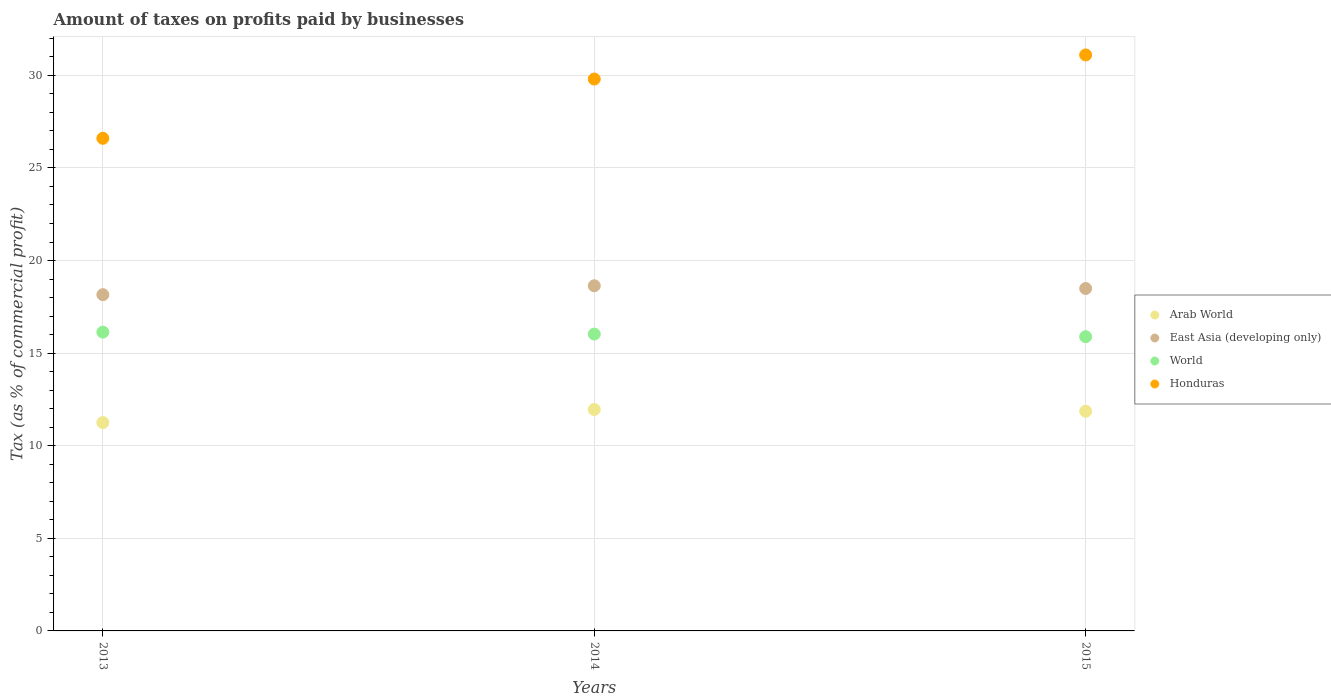What is the percentage of taxes paid by businesses in Honduras in 2013?
Offer a terse response. 26.6. Across all years, what is the maximum percentage of taxes paid by businesses in World?
Your answer should be compact. 16.13. Across all years, what is the minimum percentage of taxes paid by businesses in Arab World?
Your answer should be very brief. 11.25. In which year was the percentage of taxes paid by businesses in East Asia (developing only) maximum?
Your answer should be compact. 2014. What is the total percentage of taxes paid by businesses in East Asia (developing only) in the graph?
Ensure brevity in your answer.  55.28. What is the difference between the percentage of taxes paid by businesses in East Asia (developing only) in 2014 and that in 2015?
Provide a short and direct response. 0.15. What is the difference between the percentage of taxes paid by businesses in Arab World in 2015 and the percentage of taxes paid by businesses in East Asia (developing only) in 2013?
Keep it short and to the point. -6.29. What is the average percentage of taxes paid by businesses in Arab World per year?
Ensure brevity in your answer.  11.69. In the year 2015, what is the difference between the percentage of taxes paid by businesses in East Asia (developing only) and percentage of taxes paid by businesses in World?
Give a very brief answer. 2.6. In how many years, is the percentage of taxes paid by businesses in World greater than 23 %?
Offer a very short reply. 0. What is the ratio of the percentage of taxes paid by businesses in Arab World in 2013 to that in 2014?
Ensure brevity in your answer.  0.94. Is the difference between the percentage of taxes paid by businesses in East Asia (developing only) in 2013 and 2014 greater than the difference between the percentage of taxes paid by businesses in World in 2013 and 2014?
Offer a very short reply. No. What is the difference between the highest and the second highest percentage of taxes paid by businesses in World?
Offer a terse response. 0.11. What is the difference between the highest and the lowest percentage of taxes paid by businesses in World?
Keep it short and to the point. 0.25. Is it the case that in every year, the sum of the percentage of taxes paid by businesses in East Asia (developing only) and percentage of taxes paid by businesses in Honduras  is greater than the sum of percentage of taxes paid by businesses in World and percentage of taxes paid by businesses in Arab World?
Ensure brevity in your answer.  Yes. Is it the case that in every year, the sum of the percentage of taxes paid by businesses in Arab World and percentage of taxes paid by businesses in Honduras  is greater than the percentage of taxes paid by businesses in World?
Your answer should be very brief. Yes. Is the percentage of taxes paid by businesses in Arab World strictly greater than the percentage of taxes paid by businesses in Honduras over the years?
Offer a terse response. No. Is the percentage of taxes paid by businesses in Arab World strictly less than the percentage of taxes paid by businesses in World over the years?
Offer a very short reply. Yes. How many dotlines are there?
Offer a very short reply. 4. How many years are there in the graph?
Make the answer very short. 3. Are the values on the major ticks of Y-axis written in scientific E-notation?
Ensure brevity in your answer.  No. Does the graph contain any zero values?
Offer a very short reply. No. Does the graph contain grids?
Offer a very short reply. Yes. Where does the legend appear in the graph?
Your answer should be very brief. Center right. How many legend labels are there?
Your response must be concise. 4. What is the title of the graph?
Give a very brief answer. Amount of taxes on profits paid by businesses. What is the label or title of the X-axis?
Keep it short and to the point. Years. What is the label or title of the Y-axis?
Provide a succinct answer. Tax (as % of commercial profit). What is the Tax (as % of commercial profit) of Arab World in 2013?
Your response must be concise. 11.25. What is the Tax (as % of commercial profit) in East Asia (developing only) in 2013?
Provide a short and direct response. 18.16. What is the Tax (as % of commercial profit) of World in 2013?
Make the answer very short. 16.13. What is the Tax (as % of commercial profit) in Honduras in 2013?
Offer a very short reply. 26.6. What is the Tax (as % of commercial profit) of Arab World in 2014?
Offer a terse response. 11.96. What is the Tax (as % of commercial profit) of East Asia (developing only) in 2014?
Keep it short and to the point. 18.64. What is the Tax (as % of commercial profit) of World in 2014?
Make the answer very short. 16.03. What is the Tax (as % of commercial profit) of Honduras in 2014?
Offer a very short reply. 29.8. What is the Tax (as % of commercial profit) in Arab World in 2015?
Your answer should be very brief. 11.86. What is the Tax (as % of commercial profit) of East Asia (developing only) in 2015?
Provide a short and direct response. 18.49. What is the Tax (as % of commercial profit) of World in 2015?
Offer a terse response. 15.89. What is the Tax (as % of commercial profit) of Honduras in 2015?
Provide a short and direct response. 31.1. Across all years, what is the maximum Tax (as % of commercial profit) in Arab World?
Ensure brevity in your answer.  11.96. Across all years, what is the maximum Tax (as % of commercial profit) in East Asia (developing only)?
Offer a very short reply. 18.64. Across all years, what is the maximum Tax (as % of commercial profit) in World?
Provide a succinct answer. 16.13. Across all years, what is the maximum Tax (as % of commercial profit) in Honduras?
Offer a terse response. 31.1. Across all years, what is the minimum Tax (as % of commercial profit) of Arab World?
Your answer should be compact. 11.25. Across all years, what is the minimum Tax (as % of commercial profit) of East Asia (developing only)?
Your answer should be very brief. 18.16. Across all years, what is the minimum Tax (as % of commercial profit) in World?
Offer a terse response. 15.89. Across all years, what is the minimum Tax (as % of commercial profit) in Honduras?
Offer a terse response. 26.6. What is the total Tax (as % of commercial profit) in Arab World in the graph?
Give a very brief answer. 35.07. What is the total Tax (as % of commercial profit) in East Asia (developing only) in the graph?
Offer a terse response. 55.28. What is the total Tax (as % of commercial profit) in World in the graph?
Make the answer very short. 48.05. What is the total Tax (as % of commercial profit) in Honduras in the graph?
Provide a succinct answer. 87.5. What is the difference between the Tax (as % of commercial profit) in Arab World in 2013 and that in 2014?
Your answer should be compact. -0.71. What is the difference between the Tax (as % of commercial profit) of East Asia (developing only) in 2013 and that in 2014?
Ensure brevity in your answer.  -0.48. What is the difference between the Tax (as % of commercial profit) in World in 2013 and that in 2014?
Keep it short and to the point. 0.11. What is the difference between the Tax (as % of commercial profit) in Arab World in 2013 and that in 2015?
Provide a succinct answer. -0.61. What is the difference between the Tax (as % of commercial profit) in East Asia (developing only) in 2013 and that in 2015?
Your answer should be compact. -0.33. What is the difference between the Tax (as % of commercial profit) in World in 2013 and that in 2015?
Provide a succinct answer. 0.25. What is the difference between the Tax (as % of commercial profit) of Arab World in 2014 and that in 2015?
Your answer should be compact. 0.1. What is the difference between the Tax (as % of commercial profit) of East Asia (developing only) in 2014 and that in 2015?
Provide a succinct answer. 0.15. What is the difference between the Tax (as % of commercial profit) of World in 2014 and that in 2015?
Ensure brevity in your answer.  0.14. What is the difference between the Tax (as % of commercial profit) of Honduras in 2014 and that in 2015?
Make the answer very short. -1.3. What is the difference between the Tax (as % of commercial profit) in Arab World in 2013 and the Tax (as % of commercial profit) in East Asia (developing only) in 2014?
Your answer should be very brief. -7.39. What is the difference between the Tax (as % of commercial profit) of Arab World in 2013 and the Tax (as % of commercial profit) of World in 2014?
Provide a succinct answer. -4.78. What is the difference between the Tax (as % of commercial profit) in Arab World in 2013 and the Tax (as % of commercial profit) in Honduras in 2014?
Offer a terse response. -18.55. What is the difference between the Tax (as % of commercial profit) in East Asia (developing only) in 2013 and the Tax (as % of commercial profit) in World in 2014?
Ensure brevity in your answer.  2.13. What is the difference between the Tax (as % of commercial profit) in East Asia (developing only) in 2013 and the Tax (as % of commercial profit) in Honduras in 2014?
Give a very brief answer. -11.64. What is the difference between the Tax (as % of commercial profit) of World in 2013 and the Tax (as % of commercial profit) of Honduras in 2014?
Your answer should be very brief. -13.67. What is the difference between the Tax (as % of commercial profit) of Arab World in 2013 and the Tax (as % of commercial profit) of East Asia (developing only) in 2015?
Your response must be concise. -7.24. What is the difference between the Tax (as % of commercial profit) of Arab World in 2013 and the Tax (as % of commercial profit) of World in 2015?
Keep it short and to the point. -4.64. What is the difference between the Tax (as % of commercial profit) in Arab World in 2013 and the Tax (as % of commercial profit) in Honduras in 2015?
Your answer should be very brief. -19.85. What is the difference between the Tax (as % of commercial profit) of East Asia (developing only) in 2013 and the Tax (as % of commercial profit) of World in 2015?
Give a very brief answer. 2.27. What is the difference between the Tax (as % of commercial profit) of East Asia (developing only) in 2013 and the Tax (as % of commercial profit) of Honduras in 2015?
Provide a succinct answer. -12.94. What is the difference between the Tax (as % of commercial profit) of World in 2013 and the Tax (as % of commercial profit) of Honduras in 2015?
Provide a short and direct response. -14.97. What is the difference between the Tax (as % of commercial profit) in Arab World in 2014 and the Tax (as % of commercial profit) in East Asia (developing only) in 2015?
Give a very brief answer. -6.53. What is the difference between the Tax (as % of commercial profit) in Arab World in 2014 and the Tax (as % of commercial profit) in World in 2015?
Give a very brief answer. -3.93. What is the difference between the Tax (as % of commercial profit) of Arab World in 2014 and the Tax (as % of commercial profit) of Honduras in 2015?
Offer a terse response. -19.14. What is the difference between the Tax (as % of commercial profit) of East Asia (developing only) in 2014 and the Tax (as % of commercial profit) of World in 2015?
Offer a terse response. 2.75. What is the difference between the Tax (as % of commercial profit) of East Asia (developing only) in 2014 and the Tax (as % of commercial profit) of Honduras in 2015?
Offer a very short reply. -12.46. What is the difference between the Tax (as % of commercial profit) of World in 2014 and the Tax (as % of commercial profit) of Honduras in 2015?
Make the answer very short. -15.07. What is the average Tax (as % of commercial profit) of Arab World per year?
Your response must be concise. 11.69. What is the average Tax (as % of commercial profit) in East Asia (developing only) per year?
Offer a terse response. 18.43. What is the average Tax (as % of commercial profit) of World per year?
Give a very brief answer. 16.02. What is the average Tax (as % of commercial profit) of Honduras per year?
Provide a short and direct response. 29.17. In the year 2013, what is the difference between the Tax (as % of commercial profit) in Arab World and Tax (as % of commercial profit) in East Asia (developing only)?
Your answer should be compact. -6.91. In the year 2013, what is the difference between the Tax (as % of commercial profit) of Arab World and Tax (as % of commercial profit) of World?
Give a very brief answer. -4.88. In the year 2013, what is the difference between the Tax (as % of commercial profit) in Arab World and Tax (as % of commercial profit) in Honduras?
Keep it short and to the point. -15.35. In the year 2013, what is the difference between the Tax (as % of commercial profit) in East Asia (developing only) and Tax (as % of commercial profit) in World?
Your answer should be very brief. 2.02. In the year 2013, what is the difference between the Tax (as % of commercial profit) in East Asia (developing only) and Tax (as % of commercial profit) in Honduras?
Your answer should be very brief. -8.44. In the year 2013, what is the difference between the Tax (as % of commercial profit) in World and Tax (as % of commercial profit) in Honduras?
Make the answer very short. -10.47. In the year 2014, what is the difference between the Tax (as % of commercial profit) of Arab World and Tax (as % of commercial profit) of East Asia (developing only)?
Offer a terse response. -6.68. In the year 2014, what is the difference between the Tax (as % of commercial profit) of Arab World and Tax (as % of commercial profit) of World?
Provide a short and direct response. -4.07. In the year 2014, what is the difference between the Tax (as % of commercial profit) of Arab World and Tax (as % of commercial profit) of Honduras?
Your answer should be compact. -17.84. In the year 2014, what is the difference between the Tax (as % of commercial profit) in East Asia (developing only) and Tax (as % of commercial profit) in World?
Offer a very short reply. 2.61. In the year 2014, what is the difference between the Tax (as % of commercial profit) in East Asia (developing only) and Tax (as % of commercial profit) in Honduras?
Offer a terse response. -11.16. In the year 2014, what is the difference between the Tax (as % of commercial profit) in World and Tax (as % of commercial profit) in Honduras?
Your response must be concise. -13.77. In the year 2015, what is the difference between the Tax (as % of commercial profit) of Arab World and Tax (as % of commercial profit) of East Asia (developing only)?
Provide a short and direct response. -6.63. In the year 2015, what is the difference between the Tax (as % of commercial profit) in Arab World and Tax (as % of commercial profit) in World?
Your response must be concise. -4.03. In the year 2015, what is the difference between the Tax (as % of commercial profit) in Arab World and Tax (as % of commercial profit) in Honduras?
Offer a very short reply. -19.24. In the year 2015, what is the difference between the Tax (as % of commercial profit) of East Asia (developing only) and Tax (as % of commercial profit) of World?
Make the answer very short. 2.6. In the year 2015, what is the difference between the Tax (as % of commercial profit) of East Asia (developing only) and Tax (as % of commercial profit) of Honduras?
Provide a succinct answer. -12.61. In the year 2015, what is the difference between the Tax (as % of commercial profit) in World and Tax (as % of commercial profit) in Honduras?
Offer a very short reply. -15.21. What is the ratio of the Tax (as % of commercial profit) of Arab World in 2013 to that in 2014?
Give a very brief answer. 0.94. What is the ratio of the Tax (as % of commercial profit) in East Asia (developing only) in 2013 to that in 2014?
Provide a succinct answer. 0.97. What is the ratio of the Tax (as % of commercial profit) in World in 2013 to that in 2014?
Ensure brevity in your answer.  1.01. What is the ratio of the Tax (as % of commercial profit) in Honduras in 2013 to that in 2014?
Provide a short and direct response. 0.89. What is the ratio of the Tax (as % of commercial profit) in Arab World in 2013 to that in 2015?
Make the answer very short. 0.95. What is the ratio of the Tax (as % of commercial profit) of East Asia (developing only) in 2013 to that in 2015?
Give a very brief answer. 0.98. What is the ratio of the Tax (as % of commercial profit) in World in 2013 to that in 2015?
Offer a terse response. 1.02. What is the ratio of the Tax (as % of commercial profit) in Honduras in 2013 to that in 2015?
Provide a succinct answer. 0.86. What is the ratio of the Tax (as % of commercial profit) of World in 2014 to that in 2015?
Offer a terse response. 1.01. What is the ratio of the Tax (as % of commercial profit) of Honduras in 2014 to that in 2015?
Your answer should be compact. 0.96. What is the difference between the highest and the second highest Tax (as % of commercial profit) in Arab World?
Provide a short and direct response. 0.1. What is the difference between the highest and the second highest Tax (as % of commercial profit) of East Asia (developing only)?
Make the answer very short. 0.15. What is the difference between the highest and the second highest Tax (as % of commercial profit) of World?
Provide a succinct answer. 0.11. What is the difference between the highest and the lowest Tax (as % of commercial profit) of Arab World?
Give a very brief answer. 0.71. What is the difference between the highest and the lowest Tax (as % of commercial profit) of East Asia (developing only)?
Provide a short and direct response. 0.48. What is the difference between the highest and the lowest Tax (as % of commercial profit) in World?
Your answer should be compact. 0.25. What is the difference between the highest and the lowest Tax (as % of commercial profit) of Honduras?
Make the answer very short. 4.5. 